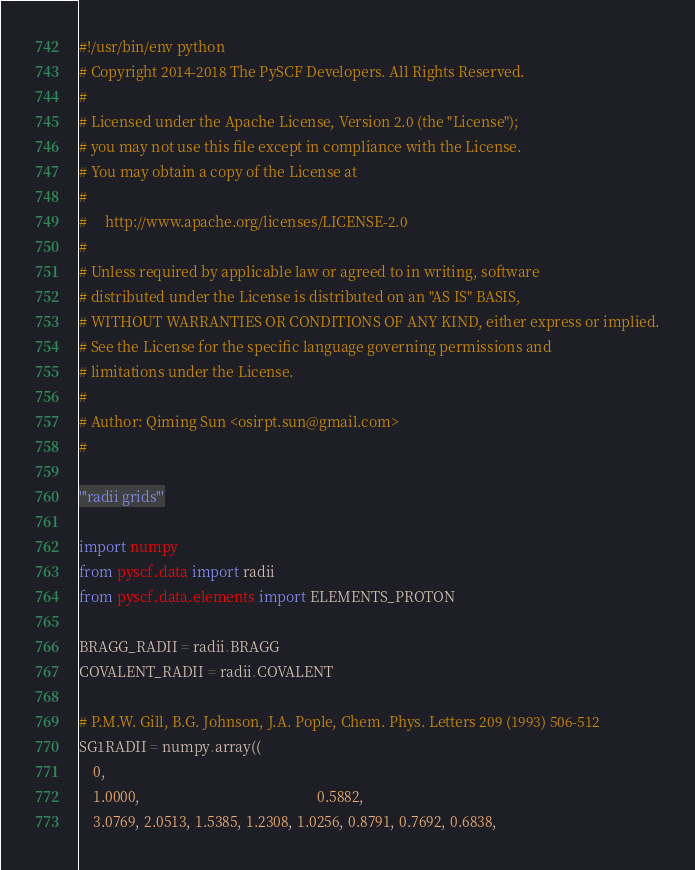Convert code to text. <code><loc_0><loc_0><loc_500><loc_500><_Python_>#!/usr/bin/env python
# Copyright 2014-2018 The PySCF Developers. All Rights Reserved.
#
# Licensed under the Apache License, Version 2.0 (the "License");
# you may not use this file except in compliance with the License.
# You may obtain a copy of the License at
#
#     http://www.apache.org/licenses/LICENSE-2.0
#
# Unless required by applicable law or agreed to in writing, software
# distributed under the License is distributed on an "AS IS" BASIS,
# WITHOUT WARRANTIES OR CONDITIONS OF ANY KIND, either express or implied.
# See the License for the specific language governing permissions and
# limitations under the License.
#
# Author: Qiming Sun <osirpt.sun@gmail.com>
#

'''radii grids'''

import numpy
from pyscf.data import radii
from pyscf.data.elements import ELEMENTS_PROTON

BRAGG_RADII = radii.BRAGG
COVALENT_RADII = radii.COVALENT

# P.M.W. Gill, B.G. Johnson, J.A. Pople, Chem. Phys. Letters 209 (1993) 506-512
SG1RADII = numpy.array((
    0,
    1.0000,                                                 0.5882,
    3.0769, 2.0513, 1.5385, 1.2308, 1.0256, 0.8791, 0.7692, 0.6838,</code> 